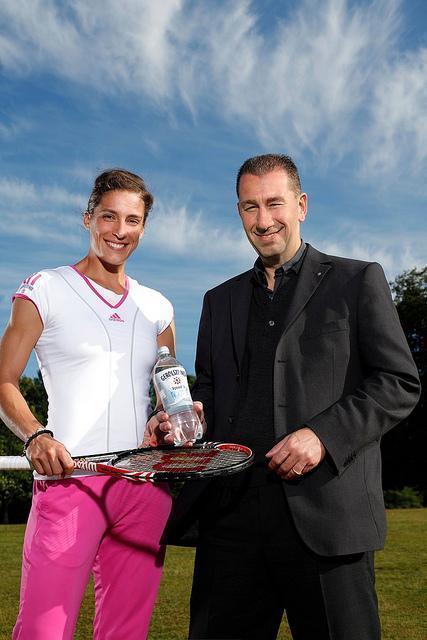What corporation made the shirt the woman is wearing?
Indicate the correct response and explain using: 'Answer: answer
Rationale: rationale.'
Options: Adidas, new balance, hanes, everlast. Answer: adidas.
Rationale: The corporation is adidas. 